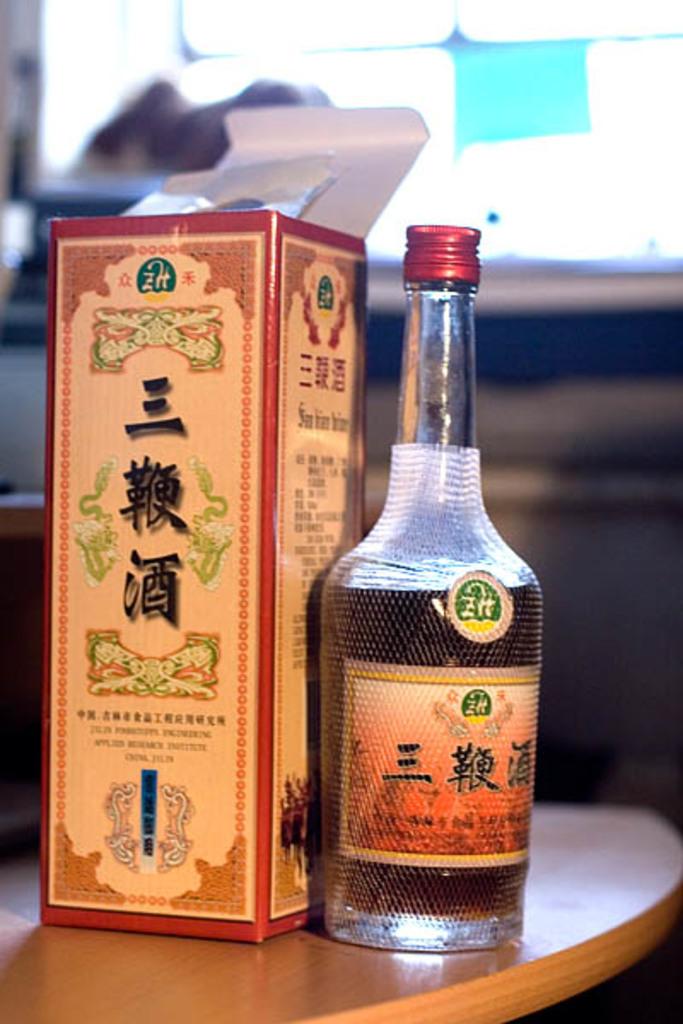Is this alcohol?
Offer a terse response. Unanswerable. 